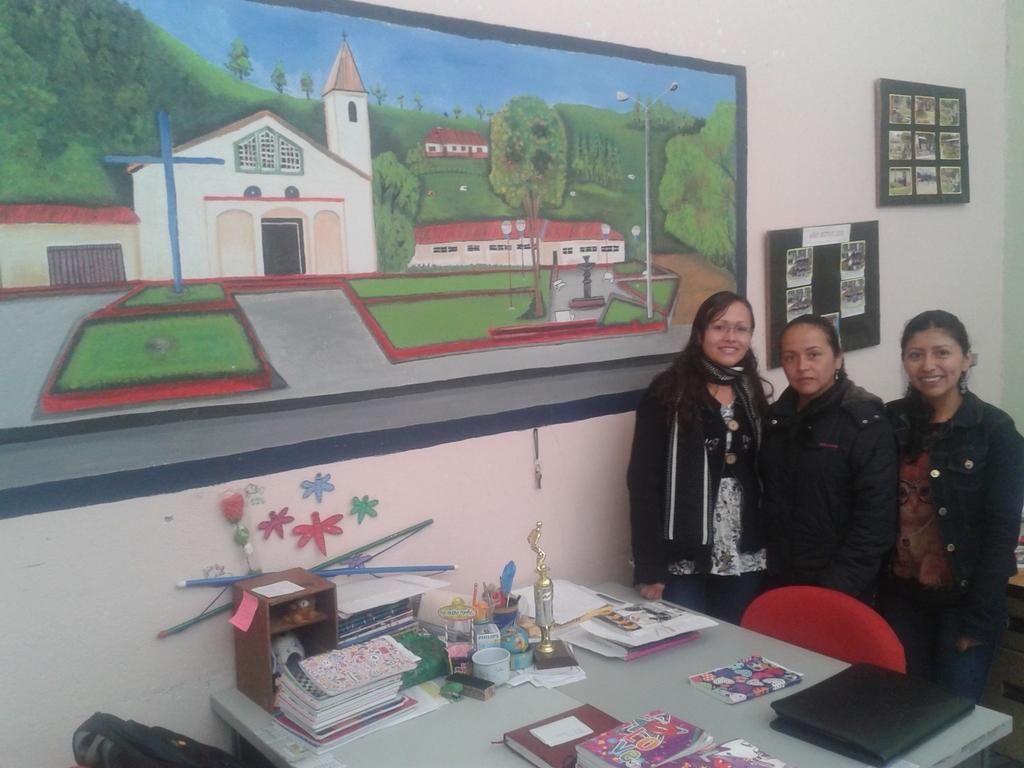Please provide a concise description of this image. This picture is clicked inside the room. Here, we see three women standing in front of table on which many books, file, cup and a box are placed. Behind that, we see a wall which is white in color and we even see a board in which house, hill and many trees are painted on it. We even see a notice board on which many posters are pasted. 